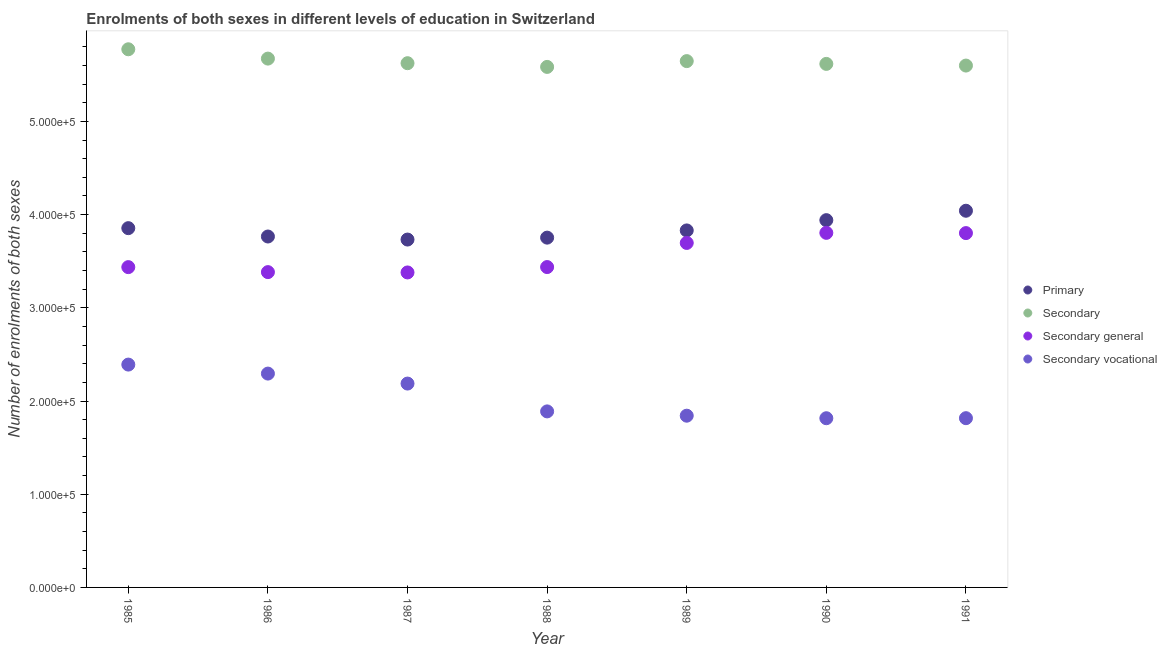How many different coloured dotlines are there?
Provide a succinct answer. 4. What is the number of enrolments in secondary vocational education in 1989?
Provide a succinct answer. 1.84e+05. Across all years, what is the maximum number of enrolments in secondary education?
Your answer should be compact. 5.77e+05. Across all years, what is the minimum number of enrolments in secondary education?
Your answer should be compact. 5.58e+05. In which year was the number of enrolments in secondary vocational education maximum?
Offer a very short reply. 1985. What is the total number of enrolments in secondary general education in the graph?
Your response must be concise. 2.49e+06. What is the difference between the number of enrolments in primary education in 1989 and that in 1990?
Make the answer very short. -1.10e+04. What is the difference between the number of enrolments in secondary education in 1989 and the number of enrolments in primary education in 1990?
Ensure brevity in your answer.  1.71e+05. What is the average number of enrolments in primary education per year?
Your answer should be compact. 3.85e+05. In the year 1991, what is the difference between the number of enrolments in secondary general education and number of enrolments in secondary vocational education?
Offer a very short reply. 1.99e+05. What is the ratio of the number of enrolments in secondary education in 1985 to that in 1990?
Your answer should be compact. 1.03. Is the difference between the number of enrolments in secondary education in 1990 and 1991 greater than the difference between the number of enrolments in secondary general education in 1990 and 1991?
Your answer should be very brief. Yes. What is the difference between the highest and the second highest number of enrolments in secondary general education?
Offer a terse response. 265. What is the difference between the highest and the lowest number of enrolments in secondary general education?
Your response must be concise. 4.25e+04. In how many years, is the number of enrolments in primary education greater than the average number of enrolments in primary education taken over all years?
Make the answer very short. 3. Is it the case that in every year, the sum of the number of enrolments in primary education and number of enrolments in secondary vocational education is greater than the sum of number of enrolments in secondary general education and number of enrolments in secondary education?
Your answer should be very brief. No. Is the number of enrolments in secondary general education strictly less than the number of enrolments in secondary education over the years?
Keep it short and to the point. Yes. What is the difference between two consecutive major ticks on the Y-axis?
Keep it short and to the point. 1.00e+05. Are the values on the major ticks of Y-axis written in scientific E-notation?
Provide a short and direct response. Yes. Does the graph contain any zero values?
Provide a succinct answer. No. Does the graph contain grids?
Make the answer very short. No. How many legend labels are there?
Ensure brevity in your answer.  4. How are the legend labels stacked?
Ensure brevity in your answer.  Vertical. What is the title of the graph?
Provide a succinct answer. Enrolments of both sexes in different levels of education in Switzerland. What is the label or title of the Y-axis?
Provide a succinct answer. Number of enrolments of both sexes. What is the Number of enrolments of both sexes in Primary in 1985?
Keep it short and to the point. 3.85e+05. What is the Number of enrolments of both sexes in Secondary in 1985?
Provide a succinct answer. 5.77e+05. What is the Number of enrolments of both sexes in Secondary general in 1985?
Your answer should be compact. 3.44e+05. What is the Number of enrolments of both sexes of Secondary vocational in 1985?
Give a very brief answer. 2.39e+05. What is the Number of enrolments of both sexes of Primary in 1986?
Offer a very short reply. 3.77e+05. What is the Number of enrolments of both sexes of Secondary in 1986?
Your answer should be very brief. 5.67e+05. What is the Number of enrolments of both sexes in Secondary general in 1986?
Provide a short and direct response. 3.38e+05. What is the Number of enrolments of both sexes in Secondary vocational in 1986?
Ensure brevity in your answer.  2.29e+05. What is the Number of enrolments of both sexes of Primary in 1987?
Your response must be concise. 3.73e+05. What is the Number of enrolments of both sexes in Secondary in 1987?
Your response must be concise. 5.62e+05. What is the Number of enrolments of both sexes in Secondary general in 1987?
Make the answer very short. 3.38e+05. What is the Number of enrolments of both sexes of Secondary vocational in 1987?
Provide a short and direct response. 2.19e+05. What is the Number of enrolments of both sexes of Primary in 1988?
Ensure brevity in your answer.  3.75e+05. What is the Number of enrolments of both sexes of Secondary in 1988?
Ensure brevity in your answer.  5.58e+05. What is the Number of enrolments of both sexes of Secondary general in 1988?
Ensure brevity in your answer.  3.44e+05. What is the Number of enrolments of both sexes in Secondary vocational in 1988?
Your response must be concise. 1.89e+05. What is the Number of enrolments of both sexes of Primary in 1989?
Make the answer very short. 3.83e+05. What is the Number of enrolments of both sexes in Secondary in 1989?
Give a very brief answer. 5.65e+05. What is the Number of enrolments of both sexes in Secondary general in 1989?
Provide a succinct answer. 3.70e+05. What is the Number of enrolments of both sexes in Secondary vocational in 1989?
Make the answer very short. 1.84e+05. What is the Number of enrolments of both sexes in Primary in 1990?
Ensure brevity in your answer.  3.94e+05. What is the Number of enrolments of both sexes in Secondary in 1990?
Your answer should be compact. 5.62e+05. What is the Number of enrolments of both sexes of Secondary general in 1990?
Your answer should be compact. 3.80e+05. What is the Number of enrolments of both sexes of Secondary vocational in 1990?
Your answer should be very brief. 1.82e+05. What is the Number of enrolments of both sexes of Primary in 1991?
Your answer should be compact. 4.04e+05. What is the Number of enrolments of both sexes in Secondary in 1991?
Provide a succinct answer. 5.60e+05. What is the Number of enrolments of both sexes in Secondary general in 1991?
Offer a very short reply. 3.80e+05. What is the Number of enrolments of both sexes of Secondary vocational in 1991?
Your answer should be very brief. 1.82e+05. Across all years, what is the maximum Number of enrolments of both sexes in Primary?
Your answer should be compact. 4.04e+05. Across all years, what is the maximum Number of enrolments of both sexes in Secondary?
Provide a succinct answer. 5.77e+05. Across all years, what is the maximum Number of enrolments of both sexes in Secondary general?
Make the answer very short. 3.80e+05. Across all years, what is the maximum Number of enrolments of both sexes in Secondary vocational?
Provide a succinct answer. 2.39e+05. Across all years, what is the minimum Number of enrolments of both sexes in Primary?
Your response must be concise. 3.73e+05. Across all years, what is the minimum Number of enrolments of both sexes in Secondary?
Ensure brevity in your answer.  5.58e+05. Across all years, what is the minimum Number of enrolments of both sexes in Secondary general?
Ensure brevity in your answer.  3.38e+05. Across all years, what is the minimum Number of enrolments of both sexes in Secondary vocational?
Provide a short and direct response. 1.82e+05. What is the total Number of enrolments of both sexes of Primary in the graph?
Give a very brief answer. 2.69e+06. What is the total Number of enrolments of both sexes in Secondary in the graph?
Your answer should be very brief. 3.95e+06. What is the total Number of enrolments of both sexes of Secondary general in the graph?
Ensure brevity in your answer.  2.49e+06. What is the total Number of enrolments of both sexes in Secondary vocational in the graph?
Ensure brevity in your answer.  1.42e+06. What is the difference between the Number of enrolments of both sexes of Primary in 1985 and that in 1986?
Keep it short and to the point. 8962. What is the difference between the Number of enrolments of both sexes in Secondary in 1985 and that in 1986?
Offer a very short reply. 1.00e+04. What is the difference between the Number of enrolments of both sexes in Secondary general in 1985 and that in 1986?
Your response must be concise. 5355. What is the difference between the Number of enrolments of both sexes in Secondary vocational in 1985 and that in 1986?
Give a very brief answer. 9661. What is the difference between the Number of enrolments of both sexes in Primary in 1985 and that in 1987?
Your response must be concise. 1.22e+04. What is the difference between the Number of enrolments of both sexes of Secondary in 1985 and that in 1987?
Your response must be concise. 1.49e+04. What is the difference between the Number of enrolments of both sexes in Secondary general in 1985 and that in 1987?
Make the answer very short. 5704. What is the difference between the Number of enrolments of both sexes in Secondary vocational in 1985 and that in 1987?
Keep it short and to the point. 2.04e+04. What is the difference between the Number of enrolments of both sexes of Primary in 1985 and that in 1988?
Give a very brief answer. 1.02e+04. What is the difference between the Number of enrolments of both sexes of Secondary in 1985 and that in 1988?
Ensure brevity in your answer.  1.89e+04. What is the difference between the Number of enrolments of both sexes in Secondary general in 1985 and that in 1988?
Offer a terse response. -73. What is the difference between the Number of enrolments of both sexes in Secondary vocational in 1985 and that in 1988?
Make the answer very short. 5.02e+04. What is the difference between the Number of enrolments of both sexes in Primary in 1985 and that in 1989?
Keep it short and to the point. 2432. What is the difference between the Number of enrolments of both sexes in Secondary in 1985 and that in 1989?
Keep it short and to the point. 1.27e+04. What is the difference between the Number of enrolments of both sexes of Secondary general in 1985 and that in 1989?
Keep it short and to the point. -2.60e+04. What is the difference between the Number of enrolments of both sexes in Secondary vocational in 1985 and that in 1989?
Give a very brief answer. 5.48e+04. What is the difference between the Number of enrolments of both sexes in Primary in 1985 and that in 1990?
Your answer should be compact. -8587. What is the difference between the Number of enrolments of both sexes in Secondary in 1985 and that in 1990?
Your answer should be very brief. 1.57e+04. What is the difference between the Number of enrolments of both sexes in Secondary general in 1985 and that in 1990?
Ensure brevity in your answer.  -3.68e+04. What is the difference between the Number of enrolments of both sexes of Secondary vocational in 1985 and that in 1990?
Your answer should be very brief. 5.76e+04. What is the difference between the Number of enrolments of both sexes in Primary in 1985 and that in 1991?
Offer a very short reply. -1.87e+04. What is the difference between the Number of enrolments of both sexes in Secondary in 1985 and that in 1991?
Keep it short and to the point. 1.75e+04. What is the difference between the Number of enrolments of both sexes of Secondary general in 1985 and that in 1991?
Your answer should be very brief. -3.65e+04. What is the difference between the Number of enrolments of both sexes of Secondary vocational in 1985 and that in 1991?
Your answer should be very brief. 5.75e+04. What is the difference between the Number of enrolments of both sexes of Primary in 1986 and that in 1987?
Your response must be concise. 3267. What is the difference between the Number of enrolments of both sexes in Secondary in 1986 and that in 1987?
Provide a succinct answer. 4931. What is the difference between the Number of enrolments of both sexes in Secondary general in 1986 and that in 1987?
Your answer should be very brief. 349. What is the difference between the Number of enrolments of both sexes of Secondary vocational in 1986 and that in 1987?
Ensure brevity in your answer.  1.07e+04. What is the difference between the Number of enrolments of both sexes in Primary in 1986 and that in 1988?
Make the answer very short. 1210. What is the difference between the Number of enrolments of both sexes of Secondary in 1986 and that in 1988?
Provide a short and direct response. 8909. What is the difference between the Number of enrolments of both sexes in Secondary general in 1986 and that in 1988?
Provide a short and direct response. -5428. What is the difference between the Number of enrolments of both sexes of Secondary vocational in 1986 and that in 1988?
Your response must be concise. 4.06e+04. What is the difference between the Number of enrolments of both sexes of Primary in 1986 and that in 1989?
Provide a short and direct response. -6530. What is the difference between the Number of enrolments of both sexes of Secondary in 1986 and that in 1989?
Your answer should be compact. 2691. What is the difference between the Number of enrolments of both sexes of Secondary general in 1986 and that in 1989?
Keep it short and to the point. -3.13e+04. What is the difference between the Number of enrolments of both sexes in Secondary vocational in 1986 and that in 1989?
Offer a terse response. 4.52e+04. What is the difference between the Number of enrolments of both sexes in Primary in 1986 and that in 1990?
Give a very brief answer. -1.75e+04. What is the difference between the Number of enrolments of both sexes in Secondary in 1986 and that in 1990?
Offer a terse response. 5680. What is the difference between the Number of enrolments of both sexes in Secondary general in 1986 and that in 1990?
Give a very brief answer. -4.21e+04. What is the difference between the Number of enrolments of both sexes in Secondary vocational in 1986 and that in 1990?
Your response must be concise. 4.79e+04. What is the difference between the Number of enrolments of both sexes in Primary in 1986 and that in 1991?
Your answer should be compact. -2.76e+04. What is the difference between the Number of enrolments of both sexes of Secondary in 1986 and that in 1991?
Provide a short and direct response. 7472. What is the difference between the Number of enrolments of both sexes of Secondary general in 1986 and that in 1991?
Provide a short and direct response. -4.19e+04. What is the difference between the Number of enrolments of both sexes in Secondary vocational in 1986 and that in 1991?
Provide a short and direct response. 4.78e+04. What is the difference between the Number of enrolments of both sexes of Primary in 1987 and that in 1988?
Offer a terse response. -2057. What is the difference between the Number of enrolments of both sexes of Secondary in 1987 and that in 1988?
Your response must be concise. 3978. What is the difference between the Number of enrolments of both sexes in Secondary general in 1987 and that in 1988?
Provide a succinct answer. -5777. What is the difference between the Number of enrolments of both sexes in Secondary vocational in 1987 and that in 1988?
Provide a short and direct response. 2.99e+04. What is the difference between the Number of enrolments of both sexes of Primary in 1987 and that in 1989?
Ensure brevity in your answer.  -9797. What is the difference between the Number of enrolments of both sexes of Secondary in 1987 and that in 1989?
Keep it short and to the point. -2240. What is the difference between the Number of enrolments of both sexes of Secondary general in 1987 and that in 1989?
Your answer should be very brief. -3.17e+04. What is the difference between the Number of enrolments of both sexes in Secondary vocational in 1987 and that in 1989?
Give a very brief answer. 3.45e+04. What is the difference between the Number of enrolments of both sexes in Primary in 1987 and that in 1990?
Your answer should be very brief. -2.08e+04. What is the difference between the Number of enrolments of both sexes of Secondary in 1987 and that in 1990?
Your answer should be compact. 749. What is the difference between the Number of enrolments of both sexes of Secondary general in 1987 and that in 1990?
Give a very brief answer. -4.25e+04. What is the difference between the Number of enrolments of both sexes in Secondary vocational in 1987 and that in 1990?
Your response must be concise. 3.72e+04. What is the difference between the Number of enrolments of both sexes of Primary in 1987 and that in 1991?
Your response must be concise. -3.09e+04. What is the difference between the Number of enrolments of both sexes of Secondary in 1987 and that in 1991?
Offer a very short reply. 2541. What is the difference between the Number of enrolments of both sexes of Secondary general in 1987 and that in 1991?
Provide a short and direct response. -4.22e+04. What is the difference between the Number of enrolments of both sexes in Secondary vocational in 1987 and that in 1991?
Provide a short and direct response. 3.71e+04. What is the difference between the Number of enrolments of both sexes in Primary in 1988 and that in 1989?
Your answer should be compact. -7740. What is the difference between the Number of enrolments of both sexes in Secondary in 1988 and that in 1989?
Provide a succinct answer. -6218. What is the difference between the Number of enrolments of both sexes of Secondary general in 1988 and that in 1989?
Your answer should be compact. -2.59e+04. What is the difference between the Number of enrolments of both sexes in Secondary vocational in 1988 and that in 1989?
Offer a terse response. 4607. What is the difference between the Number of enrolments of both sexes of Primary in 1988 and that in 1990?
Ensure brevity in your answer.  -1.88e+04. What is the difference between the Number of enrolments of both sexes in Secondary in 1988 and that in 1990?
Provide a short and direct response. -3229. What is the difference between the Number of enrolments of both sexes of Secondary general in 1988 and that in 1990?
Your response must be concise. -3.67e+04. What is the difference between the Number of enrolments of both sexes of Secondary vocational in 1988 and that in 1990?
Offer a terse response. 7331. What is the difference between the Number of enrolments of both sexes of Primary in 1988 and that in 1991?
Offer a very short reply. -2.89e+04. What is the difference between the Number of enrolments of both sexes of Secondary in 1988 and that in 1991?
Provide a succinct answer. -1437. What is the difference between the Number of enrolments of both sexes of Secondary general in 1988 and that in 1991?
Ensure brevity in your answer.  -3.64e+04. What is the difference between the Number of enrolments of both sexes of Secondary vocational in 1988 and that in 1991?
Ensure brevity in your answer.  7276. What is the difference between the Number of enrolments of both sexes in Primary in 1989 and that in 1990?
Give a very brief answer. -1.10e+04. What is the difference between the Number of enrolments of both sexes in Secondary in 1989 and that in 1990?
Ensure brevity in your answer.  2989. What is the difference between the Number of enrolments of both sexes in Secondary general in 1989 and that in 1990?
Make the answer very short. -1.08e+04. What is the difference between the Number of enrolments of both sexes of Secondary vocational in 1989 and that in 1990?
Offer a very short reply. 2724. What is the difference between the Number of enrolments of both sexes of Primary in 1989 and that in 1991?
Your answer should be compact. -2.11e+04. What is the difference between the Number of enrolments of both sexes in Secondary in 1989 and that in 1991?
Offer a terse response. 4781. What is the difference between the Number of enrolments of both sexes in Secondary general in 1989 and that in 1991?
Your answer should be compact. -1.06e+04. What is the difference between the Number of enrolments of both sexes of Secondary vocational in 1989 and that in 1991?
Your answer should be very brief. 2669. What is the difference between the Number of enrolments of both sexes of Primary in 1990 and that in 1991?
Your response must be concise. -1.01e+04. What is the difference between the Number of enrolments of both sexes of Secondary in 1990 and that in 1991?
Give a very brief answer. 1792. What is the difference between the Number of enrolments of both sexes of Secondary general in 1990 and that in 1991?
Your answer should be compact. 265. What is the difference between the Number of enrolments of both sexes in Secondary vocational in 1990 and that in 1991?
Make the answer very short. -55. What is the difference between the Number of enrolments of both sexes in Primary in 1985 and the Number of enrolments of both sexes in Secondary in 1986?
Make the answer very short. -1.82e+05. What is the difference between the Number of enrolments of both sexes of Primary in 1985 and the Number of enrolments of both sexes of Secondary general in 1986?
Keep it short and to the point. 4.72e+04. What is the difference between the Number of enrolments of both sexes of Primary in 1985 and the Number of enrolments of both sexes of Secondary vocational in 1986?
Offer a terse response. 1.56e+05. What is the difference between the Number of enrolments of both sexes of Secondary in 1985 and the Number of enrolments of both sexes of Secondary general in 1986?
Provide a succinct answer. 2.39e+05. What is the difference between the Number of enrolments of both sexes of Secondary in 1985 and the Number of enrolments of both sexes of Secondary vocational in 1986?
Make the answer very short. 3.48e+05. What is the difference between the Number of enrolments of both sexes of Secondary general in 1985 and the Number of enrolments of both sexes of Secondary vocational in 1986?
Give a very brief answer. 1.14e+05. What is the difference between the Number of enrolments of both sexes of Primary in 1985 and the Number of enrolments of both sexes of Secondary in 1987?
Provide a succinct answer. -1.77e+05. What is the difference between the Number of enrolments of both sexes in Primary in 1985 and the Number of enrolments of both sexes in Secondary general in 1987?
Offer a terse response. 4.75e+04. What is the difference between the Number of enrolments of both sexes in Primary in 1985 and the Number of enrolments of both sexes in Secondary vocational in 1987?
Offer a terse response. 1.67e+05. What is the difference between the Number of enrolments of both sexes of Secondary in 1985 and the Number of enrolments of both sexes of Secondary general in 1987?
Make the answer very short. 2.39e+05. What is the difference between the Number of enrolments of both sexes of Secondary in 1985 and the Number of enrolments of both sexes of Secondary vocational in 1987?
Your answer should be compact. 3.59e+05. What is the difference between the Number of enrolments of both sexes in Secondary general in 1985 and the Number of enrolments of both sexes in Secondary vocational in 1987?
Provide a succinct answer. 1.25e+05. What is the difference between the Number of enrolments of both sexes of Primary in 1985 and the Number of enrolments of both sexes of Secondary in 1988?
Make the answer very short. -1.73e+05. What is the difference between the Number of enrolments of both sexes in Primary in 1985 and the Number of enrolments of both sexes in Secondary general in 1988?
Make the answer very short. 4.17e+04. What is the difference between the Number of enrolments of both sexes in Primary in 1985 and the Number of enrolments of both sexes in Secondary vocational in 1988?
Keep it short and to the point. 1.97e+05. What is the difference between the Number of enrolments of both sexes in Secondary in 1985 and the Number of enrolments of both sexes in Secondary general in 1988?
Your response must be concise. 2.34e+05. What is the difference between the Number of enrolments of both sexes in Secondary in 1985 and the Number of enrolments of both sexes in Secondary vocational in 1988?
Your answer should be very brief. 3.89e+05. What is the difference between the Number of enrolments of both sexes of Secondary general in 1985 and the Number of enrolments of both sexes of Secondary vocational in 1988?
Offer a very short reply. 1.55e+05. What is the difference between the Number of enrolments of both sexes in Primary in 1985 and the Number of enrolments of both sexes in Secondary in 1989?
Your answer should be compact. -1.79e+05. What is the difference between the Number of enrolments of both sexes of Primary in 1985 and the Number of enrolments of both sexes of Secondary general in 1989?
Give a very brief answer. 1.59e+04. What is the difference between the Number of enrolments of both sexes of Primary in 1985 and the Number of enrolments of both sexes of Secondary vocational in 1989?
Provide a succinct answer. 2.01e+05. What is the difference between the Number of enrolments of both sexes of Secondary in 1985 and the Number of enrolments of both sexes of Secondary general in 1989?
Provide a short and direct response. 2.08e+05. What is the difference between the Number of enrolments of both sexes of Secondary in 1985 and the Number of enrolments of both sexes of Secondary vocational in 1989?
Your answer should be very brief. 3.93e+05. What is the difference between the Number of enrolments of both sexes in Secondary general in 1985 and the Number of enrolments of both sexes in Secondary vocational in 1989?
Provide a short and direct response. 1.59e+05. What is the difference between the Number of enrolments of both sexes in Primary in 1985 and the Number of enrolments of both sexes in Secondary in 1990?
Make the answer very short. -1.76e+05. What is the difference between the Number of enrolments of both sexes in Primary in 1985 and the Number of enrolments of both sexes in Secondary general in 1990?
Provide a short and direct response. 5034. What is the difference between the Number of enrolments of both sexes of Primary in 1985 and the Number of enrolments of both sexes of Secondary vocational in 1990?
Ensure brevity in your answer.  2.04e+05. What is the difference between the Number of enrolments of both sexes of Secondary in 1985 and the Number of enrolments of both sexes of Secondary general in 1990?
Your answer should be compact. 1.97e+05. What is the difference between the Number of enrolments of both sexes in Secondary in 1985 and the Number of enrolments of both sexes in Secondary vocational in 1990?
Ensure brevity in your answer.  3.96e+05. What is the difference between the Number of enrolments of both sexes of Secondary general in 1985 and the Number of enrolments of both sexes of Secondary vocational in 1990?
Your answer should be very brief. 1.62e+05. What is the difference between the Number of enrolments of both sexes of Primary in 1985 and the Number of enrolments of both sexes of Secondary in 1991?
Provide a short and direct response. -1.74e+05. What is the difference between the Number of enrolments of both sexes of Primary in 1985 and the Number of enrolments of both sexes of Secondary general in 1991?
Provide a short and direct response. 5299. What is the difference between the Number of enrolments of both sexes of Primary in 1985 and the Number of enrolments of both sexes of Secondary vocational in 1991?
Provide a short and direct response. 2.04e+05. What is the difference between the Number of enrolments of both sexes in Secondary in 1985 and the Number of enrolments of both sexes in Secondary general in 1991?
Your answer should be very brief. 1.97e+05. What is the difference between the Number of enrolments of both sexes of Secondary in 1985 and the Number of enrolments of both sexes of Secondary vocational in 1991?
Keep it short and to the point. 3.96e+05. What is the difference between the Number of enrolments of both sexes of Secondary general in 1985 and the Number of enrolments of both sexes of Secondary vocational in 1991?
Your response must be concise. 1.62e+05. What is the difference between the Number of enrolments of both sexes in Primary in 1986 and the Number of enrolments of both sexes in Secondary in 1987?
Your answer should be very brief. -1.86e+05. What is the difference between the Number of enrolments of both sexes in Primary in 1986 and the Number of enrolments of both sexes in Secondary general in 1987?
Offer a terse response. 3.86e+04. What is the difference between the Number of enrolments of both sexes in Primary in 1986 and the Number of enrolments of both sexes in Secondary vocational in 1987?
Keep it short and to the point. 1.58e+05. What is the difference between the Number of enrolments of both sexes in Secondary in 1986 and the Number of enrolments of both sexes in Secondary general in 1987?
Your answer should be compact. 2.29e+05. What is the difference between the Number of enrolments of both sexes in Secondary in 1986 and the Number of enrolments of both sexes in Secondary vocational in 1987?
Your answer should be very brief. 3.49e+05. What is the difference between the Number of enrolments of both sexes in Secondary general in 1986 and the Number of enrolments of both sexes in Secondary vocational in 1987?
Provide a succinct answer. 1.20e+05. What is the difference between the Number of enrolments of both sexes of Primary in 1986 and the Number of enrolments of both sexes of Secondary in 1988?
Give a very brief answer. -1.82e+05. What is the difference between the Number of enrolments of both sexes in Primary in 1986 and the Number of enrolments of both sexes in Secondary general in 1988?
Make the answer very short. 3.28e+04. What is the difference between the Number of enrolments of both sexes of Primary in 1986 and the Number of enrolments of both sexes of Secondary vocational in 1988?
Offer a terse response. 1.88e+05. What is the difference between the Number of enrolments of both sexes of Secondary in 1986 and the Number of enrolments of both sexes of Secondary general in 1988?
Provide a short and direct response. 2.24e+05. What is the difference between the Number of enrolments of both sexes of Secondary in 1986 and the Number of enrolments of both sexes of Secondary vocational in 1988?
Keep it short and to the point. 3.79e+05. What is the difference between the Number of enrolments of both sexes in Secondary general in 1986 and the Number of enrolments of both sexes in Secondary vocational in 1988?
Keep it short and to the point. 1.49e+05. What is the difference between the Number of enrolments of both sexes in Primary in 1986 and the Number of enrolments of both sexes in Secondary in 1989?
Your answer should be very brief. -1.88e+05. What is the difference between the Number of enrolments of both sexes of Primary in 1986 and the Number of enrolments of both sexes of Secondary general in 1989?
Offer a very short reply. 6897. What is the difference between the Number of enrolments of both sexes of Primary in 1986 and the Number of enrolments of both sexes of Secondary vocational in 1989?
Ensure brevity in your answer.  1.92e+05. What is the difference between the Number of enrolments of both sexes in Secondary in 1986 and the Number of enrolments of both sexes in Secondary general in 1989?
Ensure brevity in your answer.  1.98e+05. What is the difference between the Number of enrolments of both sexes in Secondary in 1986 and the Number of enrolments of both sexes in Secondary vocational in 1989?
Offer a very short reply. 3.83e+05. What is the difference between the Number of enrolments of both sexes in Secondary general in 1986 and the Number of enrolments of both sexes in Secondary vocational in 1989?
Offer a terse response. 1.54e+05. What is the difference between the Number of enrolments of both sexes in Primary in 1986 and the Number of enrolments of both sexes in Secondary in 1990?
Give a very brief answer. -1.85e+05. What is the difference between the Number of enrolments of both sexes of Primary in 1986 and the Number of enrolments of both sexes of Secondary general in 1990?
Offer a very short reply. -3928. What is the difference between the Number of enrolments of both sexes in Primary in 1986 and the Number of enrolments of both sexes in Secondary vocational in 1990?
Your answer should be very brief. 1.95e+05. What is the difference between the Number of enrolments of both sexes of Secondary in 1986 and the Number of enrolments of both sexes of Secondary general in 1990?
Provide a short and direct response. 1.87e+05. What is the difference between the Number of enrolments of both sexes of Secondary in 1986 and the Number of enrolments of both sexes of Secondary vocational in 1990?
Offer a terse response. 3.86e+05. What is the difference between the Number of enrolments of both sexes in Secondary general in 1986 and the Number of enrolments of both sexes in Secondary vocational in 1990?
Provide a succinct answer. 1.57e+05. What is the difference between the Number of enrolments of both sexes in Primary in 1986 and the Number of enrolments of both sexes in Secondary in 1991?
Make the answer very short. -1.83e+05. What is the difference between the Number of enrolments of both sexes in Primary in 1986 and the Number of enrolments of both sexes in Secondary general in 1991?
Provide a succinct answer. -3663. What is the difference between the Number of enrolments of both sexes in Primary in 1986 and the Number of enrolments of both sexes in Secondary vocational in 1991?
Offer a terse response. 1.95e+05. What is the difference between the Number of enrolments of both sexes in Secondary in 1986 and the Number of enrolments of both sexes in Secondary general in 1991?
Your answer should be compact. 1.87e+05. What is the difference between the Number of enrolments of both sexes of Secondary in 1986 and the Number of enrolments of both sexes of Secondary vocational in 1991?
Your answer should be compact. 3.86e+05. What is the difference between the Number of enrolments of both sexes in Secondary general in 1986 and the Number of enrolments of both sexes in Secondary vocational in 1991?
Ensure brevity in your answer.  1.57e+05. What is the difference between the Number of enrolments of both sexes in Primary in 1987 and the Number of enrolments of both sexes in Secondary in 1988?
Your answer should be very brief. -1.85e+05. What is the difference between the Number of enrolments of both sexes in Primary in 1987 and the Number of enrolments of both sexes in Secondary general in 1988?
Make the answer very short. 2.95e+04. What is the difference between the Number of enrolments of both sexes in Primary in 1987 and the Number of enrolments of both sexes in Secondary vocational in 1988?
Provide a succinct answer. 1.84e+05. What is the difference between the Number of enrolments of both sexes of Secondary in 1987 and the Number of enrolments of both sexes of Secondary general in 1988?
Provide a short and direct response. 2.19e+05. What is the difference between the Number of enrolments of both sexes in Secondary in 1987 and the Number of enrolments of both sexes in Secondary vocational in 1988?
Offer a terse response. 3.74e+05. What is the difference between the Number of enrolments of both sexes of Secondary general in 1987 and the Number of enrolments of both sexes of Secondary vocational in 1988?
Offer a terse response. 1.49e+05. What is the difference between the Number of enrolments of both sexes in Primary in 1987 and the Number of enrolments of both sexes in Secondary in 1989?
Provide a short and direct response. -1.91e+05. What is the difference between the Number of enrolments of both sexes in Primary in 1987 and the Number of enrolments of both sexes in Secondary general in 1989?
Make the answer very short. 3630. What is the difference between the Number of enrolments of both sexes of Primary in 1987 and the Number of enrolments of both sexes of Secondary vocational in 1989?
Provide a succinct answer. 1.89e+05. What is the difference between the Number of enrolments of both sexes of Secondary in 1987 and the Number of enrolments of both sexes of Secondary general in 1989?
Your answer should be very brief. 1.93e+05. What is the difference between the Number of enrolments of both sexes in Secondary in 1987 and the Number of enrolments of both sexes in Secondary vocational in 1989?
Offer a terse response. 3.78e+05. What is the difference between the Number of enrolments of both sexes of Secondary general in 1987 and the Number of enrolments of both sexes of Secondary vocational in 1989?
Make the answer very short. 1.54e+05. What is the difference between the Number of enrolments of both sexes of Primary in 1987 and the Number of enrolments of both sexes of Secondary in 1990?
Your response must be concise. -1.88e+05. What is the difference between the Number of enrolments of both sexes in Primary in 1987 and the Number of enrolments of both sexes in Secondary general in 1990?
Make the answer very short. -7195. What is the difference between the Number of enrolments of both sexes in Primary in 1987 and the Number of enrolments of both sexes in Secondary vocational in 1990?
Offer a terse response. 1.92e+05. What is the difference between the Number of enrolments of both sexes in Secondary in 1987 and the Number of enrolments of both sexes in Secondary general in 1990?
Ensure brevity in your answer.  1.82e+05. What is the difference between the Number of enrolments of both sexes in Secondary in 1987 and the Number of enrolments of both sexes in Secondary vocational in 1990?
Give a very brief answer. 3.81e+05. What is the difference between the Number of enrolments of both sexes in Secondary general in 1987 and the Number of enrolments of both sexes in Secondary vocational in 1990?
Provide a short and direct response. 1.56e+05. What is the difference between the Number of enrolments of both sexes of Primary in 1987 and the Number of enrolments of both sexes of Secondary in 1991?
Give a very brief answer. -1.87e+05. What is the difference between the Number of enrolments of both sexes of Primary in 1987 and the Number of enrolments of both sexes of Secondary general in 1991?
Offer a terse response. -6930. What is the difference between the Number of enrolments of both sexes of Primary in 1987 and the Number of enrolments of both sexes of Secondary vocational in 1991?
Your response must be concise. 1.92e+05. What is the difference between the Number of enrolments of both sexes in Secondary in 1987 and the Number of enrolments of both sexes in Secondary general in 1991?
Your response must be concise. 1.82e+05. What is the difference between the Number of enrolments of both sexes in Secondary in 1987 and the Number of enrolments of both sexes in Secondary vocational in 1991?
Give a very brief answer. 3.81e+05. What is the difference between the Number of enrolments of both sexes of Secondary general in 1987 and the Number of enrolments of both sexes of Secondary vocational in 1991?
Make the answer very short. 1.56e+05. What is the difference between the Number of enrolments of both sexes in Primary in 1988 and the Number of enrolments of both sexes in Secondary in 1989?
Ensure brevity in your answer.  -1.89e+05. What is the difference between the Number of enrolments of both sexes of Primary in 1988 and the Number of enrolments of both sexes of Secondary general in 1989?
Offer a very short reply. 5687. What is the difference between the Number of enrolments of both sexes of Primary in 1988 and the Number of enrolments of both sexes of Secondary vocational in 1989?
Your answer should be compact. 1.91e+05. What is the difference between the Number of enrolments of both sexes of Secondary in 1988 and the Number of enrolments of both sexes of Secondary general in 1989?
Provide a succinct answer. 1.89e+05. What is the difference between the Number of enrolments of both sexes of Secondary in 1988 and the Number of enrolments of both sexes of Secondary vocational in 1989?
Offer a terse response. 3.74e+05. What is the difference between the Number of enrolments of both sexes in Secondary general in 1988 and the Number of enrolments of both sexes in Secondary vocational in 1989?
Your answer should be very brief. 1.59e+05. What is the difference between the Number of enrolments of both sexes of Primary in 1988 and the Number of enrolments of both sexes of Secondary in 1990?
Your answer should be compact. -1.86e+05. What is the difference between the Number of enrolments of both sexes of Primary in 1988 and the Number of enrolments of both sexes of Secondary general in 1990?
Provide a short and direct response. -5138. What is the difference between the Number of enrolments of both sexes in Primary in 1988 and the Number of enrolments of both sexes in Secondary vocational in 1990?
Your answer should be compact. 1.94e+05. What is the difference between the Number of enrolments of both sexes of Secondary in 1988 and the Number of enrolments of both sexes of Secondary general in 1990?
Provide a succinct answer. 1.78e+05. What is the difference between the Number of enrolments of both sexes of Secondary in 1988 and the Number of enrolments of both sexes of Secondary vocational in 1990?
Provide a short and direct response. 3.77e+05. What is the difference between the Number of enrolments of both sexes in Secondary general in 1988 and the Number of enrolments of both sexes in Secondary vocational in 1990?
Your answer should be compact. 1.62e+05. What is the difference between the Number of enrolments of both sexes of Primary in 1988 and the Number of enrolments of both sexes of Secondary in 1991?
Keep it short and to the point. -1.85e+05. What is the difference between the Number of enrolments of both sexes of Primary in 1988 and the Number of enrolments of both sexes of Secondary general in 1991?
Offer a very short reply. -4873. What is the difference between the Number of enrolments of both sexes in Primary in 1988 and the Number of enrolments of both sexes in Secondary vocational in 1991?
Your answer should be very brief. 1.94e+05. What is the difference between the Number of enrolments of both sexes in Secondary in 1988 and the Number of enrolments of both sexes in Secondary general in 1991?
Provide a succinct answer. 1.78e+05. What is the difference between the Number of enrolments of both sexes in Secondary in 1988 and the Number of enrolments of both sexes in Secondary vocational in 1991?
Provide a succinct answer. 3.77e+05. What is the difference between the Number of enrolments of both sexes of Secondary general in 1988 and the Number of enrolments of both sexes of Secondary vocational in 1991?
Offer a terse response. 1.62e+05. What is the difference between the Number of enrolments of both sexes of Primary in 1989 and the Number of enrolments of both sexes of Secondary in 1990?
Make the answer very short. -1.79e+05. What is the difference between the Number of enrolments of both sexes of Primary in 1989 and the Number of enrolments of both sexes of Secondary general in 1990?
Provide a short and direct response. 2602. What is the difference between the Number of enrolments of both sexes in Primary in 1989 and the Number of enrolments of both sexes in Secondary vocational in 1990?
Your answer should be very brief. 2.02e+05. What is the difference between the Number of enrolments of both sexes in Secondary in 1989 and the Number of enrolments of both sexes in Secondary general in 1990?
Keep it short and to the point. 1.84e+05. What is the difference between the Number of enrolments of both sexes in Secondary in 1989 and the Number of enrolments of both sexes in Secondary vocational in 1990?
Keep it short and to the point. 3.83e+05. What is the difference between the Number of enrolments of both sexes in Secondary general in 1989 and the Number of enrolments of both sexes in Secondary vocational in 1990?
Keep it short and to the point. 1.88e+05. What is the difference between the Number of enrolments of both sexes of Primary in 1989 and the Number of enrolments of both sexes of Secondary in 1991?
Ensure brevity in your answer.  -1.77e+05. What is the difference between the Number of enrolments of both sexes of Primary in 1989 and the Number of enrolments of both sexes of Secondary general in 1991?
Provide a short and direct response. 2867. What is the difference between the Number of enrolments of both sexes in Primary in 1989 and the Number of enrolments of both sexes in Secondary vocational in 1991?
Keep it short and to the point. 2.01e+05. What is the difference between the Number of enrolments of both sexes of Secondary in 1989 and the Number of enrolments of both sexes of Secondary general in 1991?
Offer a very short reply. 1.85e+05. What is the difference between the Number of enrolments of both sexes in Secondary in 1989 and the Number of enrolments of both sexes in Secondary vocational in 1991?
Provide a short and direct response. 3.83e+05. What is the difference between the Number of enrolments of both sexes of Secondary general in 1989 and the Number of enrolments of both sexes of Secondary vocational in 1991?
Your response must be concise. 1.88e+05. What is the difference between the Number of enrolments of both sexes of Primary in 1990 and the Number of enrolments of both sexes of Secondary in 1991?
Give a very brief answer. -1.66e+05. What is the difference between the Number of enrolments of both sexes of Primary in 1990 and the Number of enrolments of both sexes of Secondary general in 1991?
Ensure brevity in your answer.  1.39e+04. What is the difference between the Number of enrolments of both sexes in Primary in 1990 and the Number of enrolments of both sexes in Secondary vocational in 1991?
Your answer should be compact. 2.12e+05. What is the difference between the Number of enrolments of both sexes of Secondary in 1990 and the Number of enrolments of both sexes of Secondary general in 1991?
Provide a short and direct response. 1.82e+05. What is the difference between the Number of enrolments of both sexes of Secondary in 1990 and the Number of enrolments of both sexes of Secondary vocational in 1991?
Your response must be concise. 3.80e+05. What is the difference between the Number of enrolments of both sexes of Secondary general in 1990 and the Number of enrolments of both sexes of Secondary vocational in 1991?
Make the answer very short. 1.99e+05. What is the average Number of enrolments of both sexes in Primary per year?
Your response must be concise. 3.85e+05. What is the average Number of enrolments of both sexes in Secondary per year?
Provide a short and direct response. 5.65e+05. What is the average Number of enrolments of both sexes of Secondary general per year?
Your answer should be very brief. 3.56e+05. What is the average Number of enrolments of both sexes in Secondary vocational per year?
Make the answer very short. 2.03e+05. In the year 1985, what is the difference between the Number of enrolments of both sexes of Primary and Number of enrolments of both sexes of Secondary?
Give a very brief answer. -1.92e+05. In the year 1985, what is the difference between the Number of enrolments of both sexes of Primary and Number of enrolments of both sexes of Secondary general?
Ensure brevity in your answer.  4.18e+04. In the year 1985, what is the difference between the Number of enrolments of both sexes of Primary and Number of enrolments of both sexes of Secondary vocational?
Provide a succinct answer. 1.46e+05. In the year 1985, what is the difference between the Number of enrolments of both sexes in Secondary and Number of enrolments of both sexes in Secondary general?
Your response must be concise. 2.34e+05. In the year 1985, what is the difference between the Number of enrolments of both sexes of Secondary and Number of enrolments of both sexes of Secondary vocational?
Your answer should be compact. 3.38e+05. In the year 1985, what is the difference between the Number of enrolments of both sexes in Secondary general and Number of enrolments of both sexes in Secondary vocational?
Make the answer very short. 1.05e+05. In the year 1986, what is the difference between the Number of enrolments of both sexes of Primary and Number of enrolments of both sexes of Secondary?
Offer a terse response. -1.91e+05. In the year 1986, what is the difference between the Number of enrolments of both sexes in Primary and Number of enrolments of both sexes in Secondary general?
Your answer should be compact. 3.82e+04. In the year 1986, what is the difference between the Number of enrolments of both sexes of Primary and Number of enrolments of both sexes of Secondary vocational?
Offer a terse response. 1.47e+05. In the year 1986, what is the difference between the Number of enrolments of both sexes of Secondary and Number of enrolments of both sexes of Secondary general?
Offer a terse response. 2.29e+05. In the year 1986, what is the difference between the Number of enrolments of both sexes in Secondary and Number of enrolments of both sexes in Secondary vocational?
Provide a short and direct response. 3.38e+05. In the year 1986, what is the difference between the Number of enrolments of both sexes in Secondary general and Number of enrolments of both sexes in Secondary vocational?
Offer a terse response. 1.09e+05. In the year 1987, what is the difference between the Number of enrolments of both sexes of Primary and Number of enrolments of both sexes of Secondary?
Offer a very short reply. -1.89e+05. In the year 1987, what is the difference between the Number of enrolments of both sexes of Primary and Number of enrolments of both sexes of Secondary general?
Make the answer very short. 3.53e+04. In the year 1987, what is the difference between the Number of enrolments of both sexes of Primary and Number of enrolments of both sexes of Secondary vocational?
Provide a short and direct response. 1.55e+05. In the year 1987, what is the difference between the Number of enrolments of both sexes of Secondary and Number of enrolments of both sexes of Secondary general?
Ensure brevity in your answer.  2.25e+05. In the year 1987, what is the difference between the Number of enrolments of both sexes in Secondary and Number of enrolments of both sexes in Secondary vocational?
Your answer should be compact. 3.44e+05. In the year 1987, what is the difference between the Number of enrolments of both sexes in Secondary general and Number of enrolments of both sexes in Secondary vocational?
Your answer should be very brief. 1.19e+05. In the year 1988, what is the difference between the Number of enrolments of both sexes in Primary and Number of enrolments of both sexes in Secondary?
Give a very brief answer. -1.83e+05. In the year 1988, what is the difference between the Number of enrolments of both sexes of Primary and Number of enrolments of both sexes of Secondary general?
Offer a terse response. 3.16e+04. In the year 1988, what is the difference between the Number of enrolments of both sexes in Primary and Number of enrolments of both sexes in Secondary vocational?
Make the answer very short. 1.86e+05. In the year 1988, what is the difference between the Number of enrolments of both sexes in Secondary and Number of enrolments of both sexes in Secondary general?
Make the answer very short. 2.15e+05. In the year 1988, what is the difference between the Number of enrolments of both sexes of Secondary and Number of enrolments of both sexes of Secondary vocational?
Your answer should be compact. 3.70e+05. In the year 1988, what is the difference between the Number of enrolments of both sexes of Secondary general and Number of enrolments of both sexes of Secondary vocational?
Ensure brevity in your answer.  1.55e+05. In the year 1989, what is the difference between the Number of enrolments of both sexes in Primary and Number of enrolments of both sexes in Secondary?
Ensure brevity in your answer.  -1.82e+05. In the year 1989, what is the difference between the Number of enrolments of both sexes in Primary and Number of enrolments of both sexes in Secondary general?
Provide a succinct answer. 1.34e+04. In the year 1989, what is the difference between the Number of enrolments of both sexes of Primary and Number of enrolments of both sexes of Secondary vocational?
Your answer should be very brief. 1.99e+05. In the year 1989, what is the difference between the Number of enrolments of both sexes of Secondary and Number of enrolments of both sexes of Secondary general?
Your answer should be very brief. 1.95e+05. In the year 1989, what is the difference between the Number of enrolments of both sexes of Secondary and Number of enrolments of both sexes of Secondary vocational?
Your answer should be compact. 3.80e+05. In the year 1989, what is the difference between the Number of enrolments of both sexes of Secondary general and Number of enrolments of both sexes of Secondary vocational?
Make the answer very short. 1.85e+05. In the year 1990, what is the difference between the Number of enrolments of both sexes of Primary and Number of enrolments of both sexes of Secondary?
Provide a short and direct response. -1.68e+05. In the year 1990, what is the difference between the Number of enrolments of both sexes of Primary and Number of enrolments of both sexes of Secondary general?
Your response must be concise. 1.36e+04. In the year 1990, what is the difference between the Number of enrolments of both sexes in Primary and Number of enrolments of both sexes in Secondary vocational?
Provide a succinct answer. 2.13e+05. In the year 1990, what is the difference between the Number of enrolments of both sexes of Secondary and Number of enrolments of both sexes of Secondary general?
Provide a succinct answer. 1.81e+05. In the year 1990, what is the difference between the Number of enrolments of both sexes in Secondary and Number of enrolments of both sexes in Secondary vocational?
Keep it short and to the point. 3.80e+05. In the year 1990, what is the difference between the Number of enrolments of both sexes of Secondary general and Number of enrolments of both sexes of Secondary vocational?
Provide a short and direct response. 1.99e+05. In the year 1991, what is the difference between the Number of enrolments of both sexes of Primary and Number of enrolments of both sexes of Secondary?
Provide a short and direct response. -1.56e+05. In the year 1991, what is the difference between the Number of enrolments of both sexes in Primary and Number of enrolments of both sexes in Secondary general?
Make the answer very short. 2.40e+04. In the year 1991, what is the difference between the Number of enrolments of both sexes in Primary and Number of enrolments of both sexes in Secondary vocational?
Ensure brevity in your answer.  2.23e+05. In the year 1991, what is the difference between the Number of enrolments of both sexes in Secondary and Number of enrolments of both sexes in Secondary general?
Make the answer very short. 1.80e+05. In the year 1991, what is the difference between the Number of enrolments of both sexes in Secondary and Number of enrolments of both sexes in Secondary vocational?
Provide a short and direct response. 3.78e+05. In the year 1991, what is the difference between the Number of enrolments of both sexes of Secondary general and Number of enrolments of both sexes of Secondary vocational?
Offer a terse response. 1.99e+05. What is the ratio of the Number of enrolments of both sexes in Primary in 1985 to that in 1986?
Your response must be concise. 1.02. What is the ratio of the Number of enrolments of both sexes in Secondary in 1985 to that in 1986?
Your response must be concise. 1.02. What is the ratio of the Number of enrolments of both sexes in Secondary general in 1985 to that in 1986?
Your answer should be very brief. 1.02. What is the ratio of the Number of enrolments of both sexes in Secondary vocational in 1985 to that in 1986?
Ensure brevity in your answer.  1.04. What is the ratio of the Number of enrolments of both sexes in Primary in 1985 to that in 1987?
Give a very brief answer. 1.03. What is the ratio of the Number of enrolments of both sexes in Secondary in 1985 to that in 1987?
Provide a short and direct response. 1.03. What is the ratio of the Number of enrolments of both sexes in Secondary general in 1985 to that in 1987?
Your response must be concise. 1.02. What is the ratio of the Number of enrolments of both sexes of Secondary vocational in 1985 to that in 1987?
Ensure brevity in your answer.  1.09. What is the ratio of the Number of enrolments of both sexes of Primary in 1985 to that in 1988?
Your response must be concise. 1.03. What is the ratio of the Number of enrolments of both sexes of Secondary in 1985 to that in 1988?
Offer a terse response. 1.03. What is the ratio of the Number of enrolments of both sexes in Secondary vocational in 1985 to that in 1988?
Your answer should be very brief. 1.27. What is the ratio of the Number of enrolments of both sexes in Primary in 1985 to that in 1989?
Provide a succinct answer. 1.01. What is the ratio of the Number of enrolments of both sexes in Secondary in 1985 to that in 1989?
Your answer should be very brief. 1.02. What is the ratio of the Number of enrolments of both sexes of Secondary general in 1985 to that in 1989?
Offer a very short reply. 0.93. What is the ratio of the Number of enrolments of both sexes in Secondary vocational in 1985 to that in 1989?
Your response must be concise. 1.3. What is the ratio of the Number of enrolments of both sexes of Primary in 1985 to that in 1990?
Provide a short and direct response. 0.98. What is the ratio of the Number of enrolments of both sexes of Secondary in 1985 to that in 1990?
Ensure brevity in your answer.  1.03. What is the ratio of the Number of enrolments of both sexes in Secondary general in 1985 to that in 1990?
Your answer should be very brief. 0.9. What is the ratio of the Number of enrolments of both sexes of Secondary vocational in 1985 to that in 1990?
Ensure brevity in your answer.  1.32. What is the ratio of the Number of enrolments of both sexes in Primary in 1985 to that in 1991?
Make the answer very short. 0.95. What is the ratio of the Number of enrolments of both sexes of Secondary in 1985 to that in 1991?
Make the answer very short. 1.03. What is the ratio of the Number of enrolments of both sexes in Secondary general in 1985 to that in 1991?
Give a very brief answer. 0.9. What is the ratio of the Number of enrolments of both sexes in Secondary vocational in 1985 to that in 1991?
Your answer should be compact. 1.32. What is the ratio of the Number of enrolments of both sexes in Primary in 1986 to that in 1987?
Offer a very short reply. 1.01. What is the ratio of the Number of enrolments of both sexes of Secondary in 1986 to that in 1987?
Your response must be concise. 1.01. What is the ratio of the Number of enrolments of both sexes in Secondary vocational in 1986 to that in 1987?
Ensure brevity in your answer.  1.05. What is the ratio of the Number of enrolments of both sexes in Secondary in 1986 to that in 1988?
Offer a terse response. 1.02. What is the ratio of the Number of enrolments of both sexes in Secondary general in 1986 to that in 1988?
Give a very brief answer. 0.98. What is the ratio of the Number of enrolments of both sexes in Secondary vocational in 1986 to that in 1988?
Your answer should be compact. 1.21. What is the ratio of the Number of enrolments of both sexes of Primary in 1986 to that in 1989?
Make the answer very short. 0.98. What is the ratio of the Number of enrolments of both sexes of Secondary in 1986 to that in 1989?
Give a very brief answer. 1. What is the ratio of the Number of enrolments of both sexes of Secondary general in 1986 to that in 1989?
Provide a succinct answer. 0.92. What is the ratio of the Number of enrolments of both sexes in Secondary vocational in 1986 to that in 1989?
Provide a short and direct response. 1.25. What is the ratio of the Number of enrolments of both sexes in Primary in 1986 to that in 1990?
Ensure brevity in your answer.  0.96. What is the ratio of the Number of enrolments of both sexes in Secondary general in 1986 to that in 1990?
Offer a very short reply. 0.89. What is the ratio of the Number of enrolments of both sexes in Secondary vocational in 1986 to that in 1990?
Your answer should be very brief. 1.26. What is the ratio of the Number of enrolments of both sexes of Primary in 1986 to that in 1991?
Provide a short and direct response. 0.93. What is the ratio of the Number of enrolments of both sexes in Secondary in 1986 to that in 1991?
Ensure brevity in your answer.  1.01. What is the ratio of the Number of enrolments of both sexes in Secondary general in 1986 to that in 1991?
Your response must be concise. 0.89. What is the ratio of the Number of enrolments of both sexes in Secondary vocational in 1986 to that in 1991?
Provide a short and direct response. 1.26. What is the ratio of the Number of enrolments of both sexes of Primary in 1987 to that in 1988?
Your response must be concise. 0.99. What is the ratio of the Number of enrolments of both sexes of Secondary in 1987 to that in 1988?
Keep it short and to the point. 1.01. What is the ratio of the Number of enrolments of both sexes of Secondary general in 1987 to that in 1988?
Give a very brief answer. 0.98. What is the ratio of the Number of enrolments of both sexes of Secondary vocational in 1987 to that in 1988?
Give a very brief answer. 1.16. What is the ratio of the Number of enrolments of both sexes of Primary in 1987 to that in 1989?
Your response must be concise. 0.97. What is the ratio of the Number of enrolments of both sexes of Secondary general in 1987 to that in 1989?
Provide a succinct answer. 0.91. What is the ratio of the Number of enrolments of both sexes in Secondary vocational in 1987 to that in 1989?
Offer a very short reply. 1.19. What is the ratio of the Number of enrolments of both sexes in Primary in 1987 to that in 1990?
Give a very brief answer. 0.95. What is the ratio of the Number of enrolments of both sexes in Secondary general in 1987 to that in 1990?
Keep it short and to the point. 0.89. What is the ratio of the Number of enrolments of both sexes of Secondary vocational in 1987 to that in 1990?
Your answer should be compact. 1.2. What is the ratio of the Number of enrolments of both sexes of Primary in 1987 to that in 1991?
Give a very brief answer. 0.92. What is the ratio of the Number of enrolments of both sexes of Secondary in 1987 to that in 1991?
Ensure brevity in your answer.  1. What is the ratio of the Number of enrolments of both sexes in Secondary general in 1987 to that in 1991?
Ensure brevity in your answer.  0.89. What is the ratio of the Number of enrolments of both sexes in Secondary vocational in 1987 to that in 1991?
Your answer should be compact. 1.2. What is the ratio of the Number of enrolments of both sexes of Primary in 1988 to that in 1989?
Offer a very short reply. 0.98. What is the ratio of the Number of enrolments of both sexes of Secondary in 1988 to that in 1989?
Offer a very short reply. 0.99. What is the ratio of the Number of enrolments of both sexes in Secondary general in 1988 to that in 1989?
Provide a succinct answer. 0.93. What is the ratio of the Number of enrolments of both sexes in Secondary vocational in 1988 to that in 1989?
Offer a terse response. 1.02. What is the ratio of the Number of enrolments of both sexes in Secondary general in 1988 to that in 1990?
Your answer should be very brief. 0.9. What is the ratio of the Number of enrolments of both sexes of Secondary vocational in 1988 to that in 1990?
Ensure brevity in your answer.  1.04. What is the ratio of the Number of enrolments of both sexes in Primary in 1988 to that in 1991?
Your answer should be very brief. 0.93. What is the ratio of the Number of enrolments of both sexes in Secondary general in 1988 to that in 1991?
Offer a very short reply. 0.9. What is the ratio of the Number of enrolments of both sexes of Secondary vocational in 1988 to that in 1991?
Offer a terse response. 1.04. What is the ratio of the Number of enrolments of both sexes of Primary in 1989 to that in 1990?
Give a very brief answer. 0.97. What is the ratio of the Number of enrolments of both sexes in Secondary in 1989 to that in 1990?
Ensure brevity in your answer.  1.01. What is the ratio of the Number of enrolments of both sexes of Secondary general in 1989 to that in 1990?
Provide a succinct answer. 0.97. What is the ratio of the Number of enrolments of both sexes in Secondary vocational in 1989 to that in 1990?
Give a very brief answer. 1.01. What is the ratio of the Number of enrolments of both sexes of Primary in 1989 to that in 1991?
Provide a succinct answer. 0.95. What is the ratio of the Number of enrolments of both sexes in Secondary in 1989 to that in 1991?
Your response must be concise. 1.01. What is the ratio of the Number of enrolments of both sexes in Secondary general in 1989 to that in 1991?
Give a very brief answer. 0.97. What is the ratio of the Number of enrolments of both sexes of Secondary vocational in 1989 to that in 1991?
Keep it short and to the point. 1.01. What is the ratio of the Number of enrolments of both sexes of Primary in 1990 to that in 1991?
Provide a short and direct response. 0.97. What is the ratio of the Number of enrolments of both sexes in Secondary in 1990 to that in 1991?
Your response must be concise. 1. What is the ratio of the Number of enrolments of both sexes in Secondary vocational in 1990 to that in 1991?
Offer a very short reply. 1. What is the difference between the highest and the second highest Number of enrolments of both sexes in Primary?
Offer a very short reply. 1.01e+04. What is the difference between the highest and the second highest Number of enrolments of both sexes of Secondary?
Provide a short and direct response. 1.00e+04. What is the difference between the highest and the second highest Number of enrolments of both sexes of Secondary general?
Offer a very short reply. 265. What is the difference between the highest and the second highest Number of enrolments of both sexes of Secondary vocational?
Ensure brevity in your answer.  9661. What is the difference between the highest and the lowest Number of enrolments of both sexes of Primary?
Keep it short and to the point. 3.09e+04. What is the difference between the highest and the lowest Number of enrolments of both sexes of Secondary?
Provide a short and direct response. 1.89e+04. What is the difference between the highest and the lowest Number of enrolments of both sexes in Secondary general?
Keep it short and to the point. 4.25e+04. What is the difference between the highest and the lowest Number of enrolments of both sexes of Secondary vocational?
Ensure brevity in your answer.  5.76e+04. 